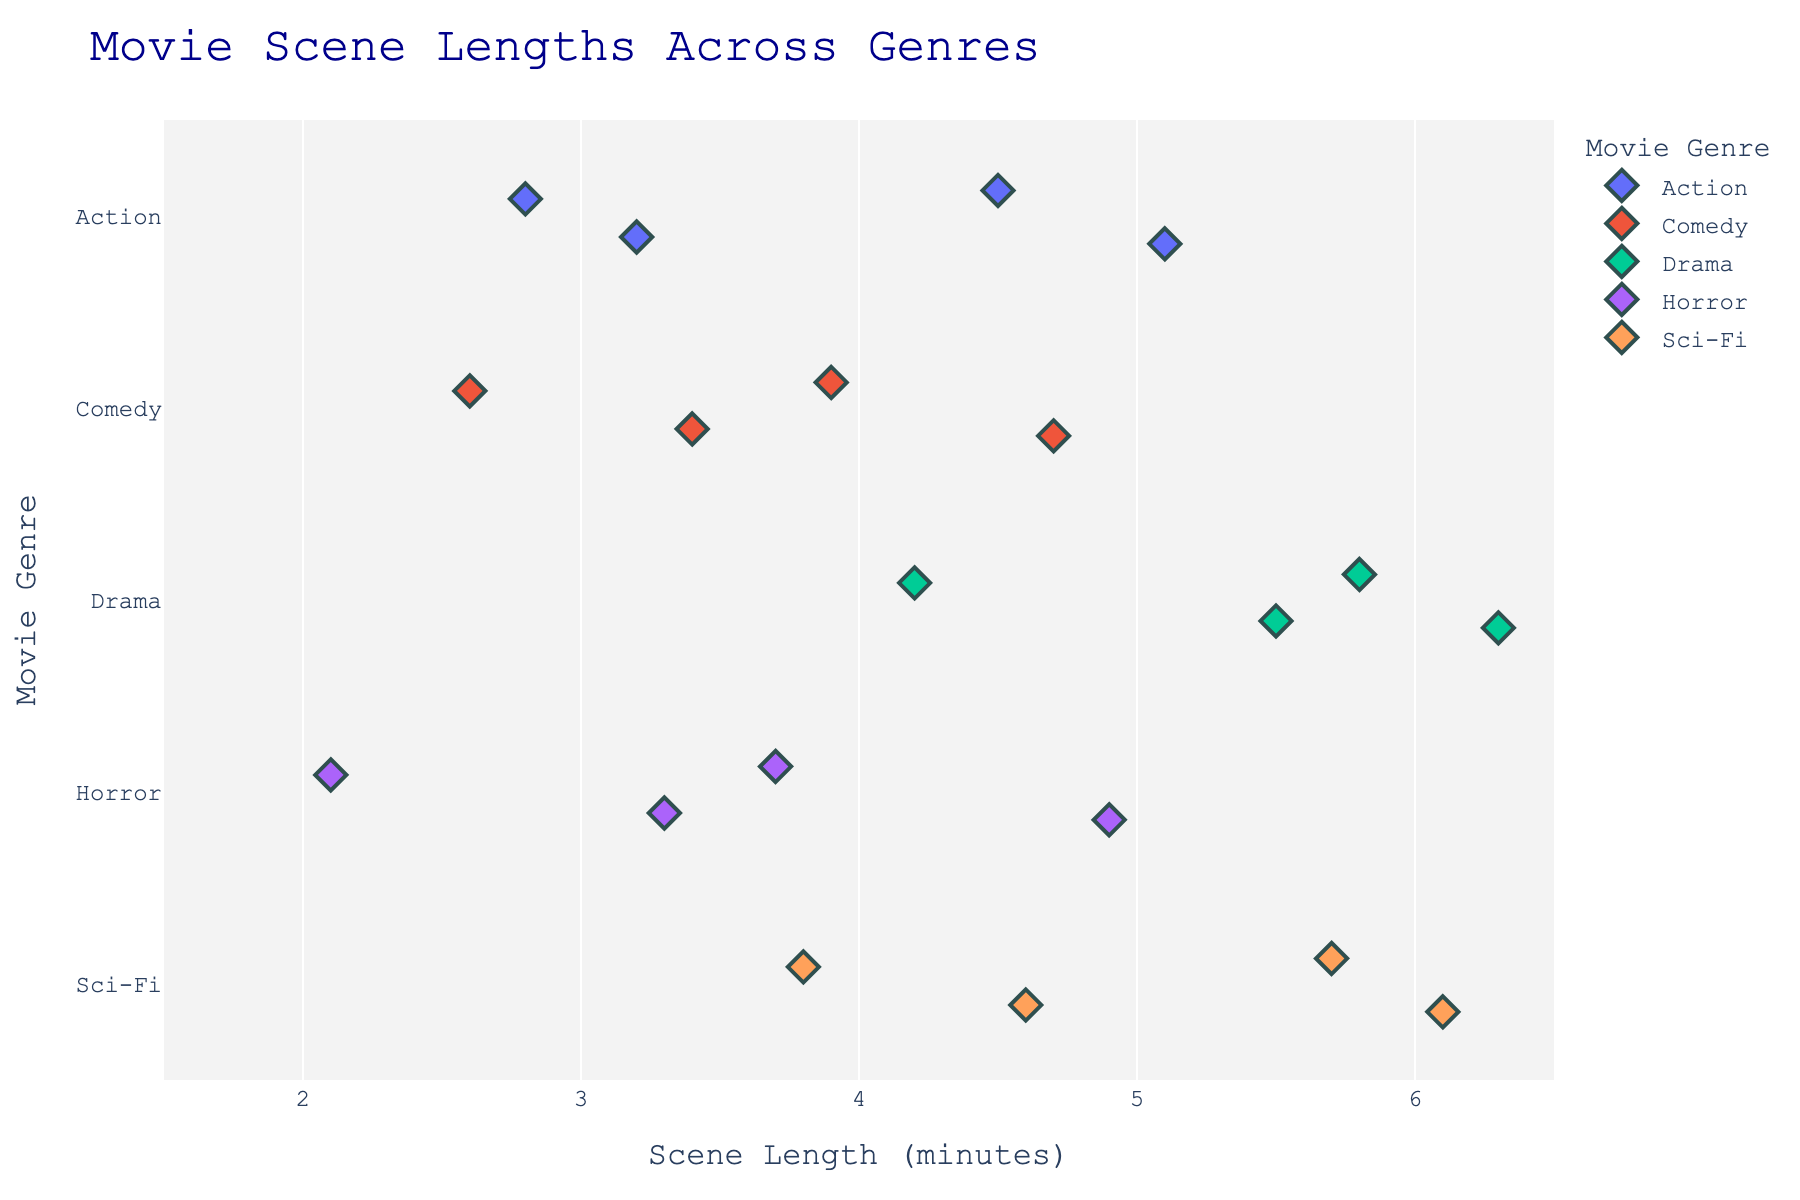What is the title of the strip plot? The title is located at the top center of the plot and is usually in a larger font size, clearly indicating the main subject of the plot.
Answer: Movie Scene Lengths Across Genres Which genre has the shortest scene in the dataset? By looking at the points grouped under each genre along the y-axis, identify the point with the smallest x-axis value (Scene Length).
Answer: Horror Which movie has the longest scene among the Drama genre? Locate the points under the Drama genre and identify the one with the highest x-axis value (Scene Length). Hover over this point to find the movie name.
Answer: The Godfather What is the range of scene lengths for Sci-Fi movies? To find the range, identify the minimum and maximum scene lengths for Sci-Fi points on the x-axis, then calculate the difference between them.
Answer: 5.7 - 3.8 = 1.9 minutes Which genre has the most tightly grouped scene lengths, indicating less variation within the genre? Look for the genre where the points are closely clustered together on the x-axis, showing less spread in scene lengths.
Answer: Drama How many movies have scene lengths greater than 5 minutes? Count the number of points that fall to the right of the 5-minute mark on the x-axis across all genres.
Answer: 4 Is there a genre where all movies have scene lengths below 4 minutes? Examine the points for each genre and check if any genre has no points extending beyond the x-axis value of 4 minutes.
Answer: Horror What can you infer about the diversity of scene lengths in the Sci-Fi genre compared to Drama? Compare the spread (variation) in the Sci-Fi genre's points to that of the Drama genre. Sci-Fi shows a wider spread from 3.8 to 6.1, whereas Drama has a narrow spread from 4.2 to 6.3. This indicates more diversity in scene lengths in Sci-Fi.
Answer: Sci-Fi shows more diversity 